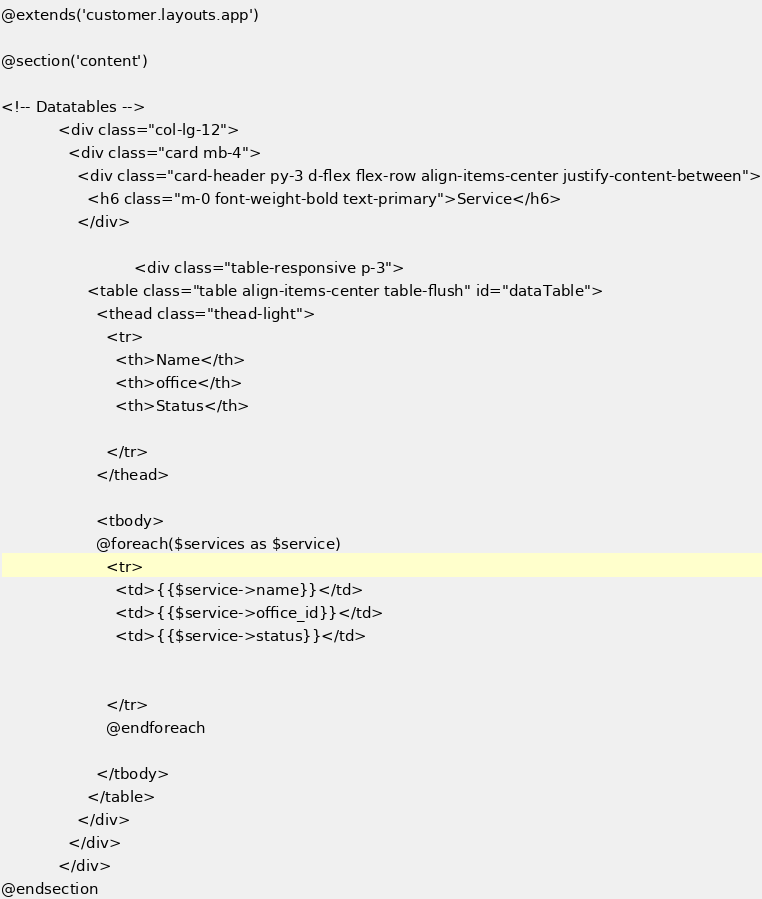<code> <loc_0><loc_0><loc_500><loc_500><_PHP_>@extends('customer.layouts.app')

@section('content')

<!-- Datatables -->
            <div class="col-lg-12">
              <div class="card mb-4">
                <div class="card-header py-3 d-flex flex-row align-items-center justify-content-between">
                  <h6 class="m-0 font-weight-bold text-primary">Service</h6>
                </div>

                            <div class="table-responsive p-3">
                  <table class="table align-items-center table-flush" id="dataTable">
                    <thead class="thead-light">
                      <tr>
                        <th>Name</th>
                        <th>office</th>
                        <th>Status</th>
                   
                      </tr>
                    </thead>
                   
                    <tbody>
                    @foreach($services as $service)
                      <tr>
                        <td>{{$service->name}}</td>
                        <td>{{$service->office_id}}</td>
                        <td>{{$service->status}}</td>
                      

                      </tr>
                      @endforeach
  
                    </tbody>
                  </table>
                </div>
              </div>
            </div>
@endsection
</code> 